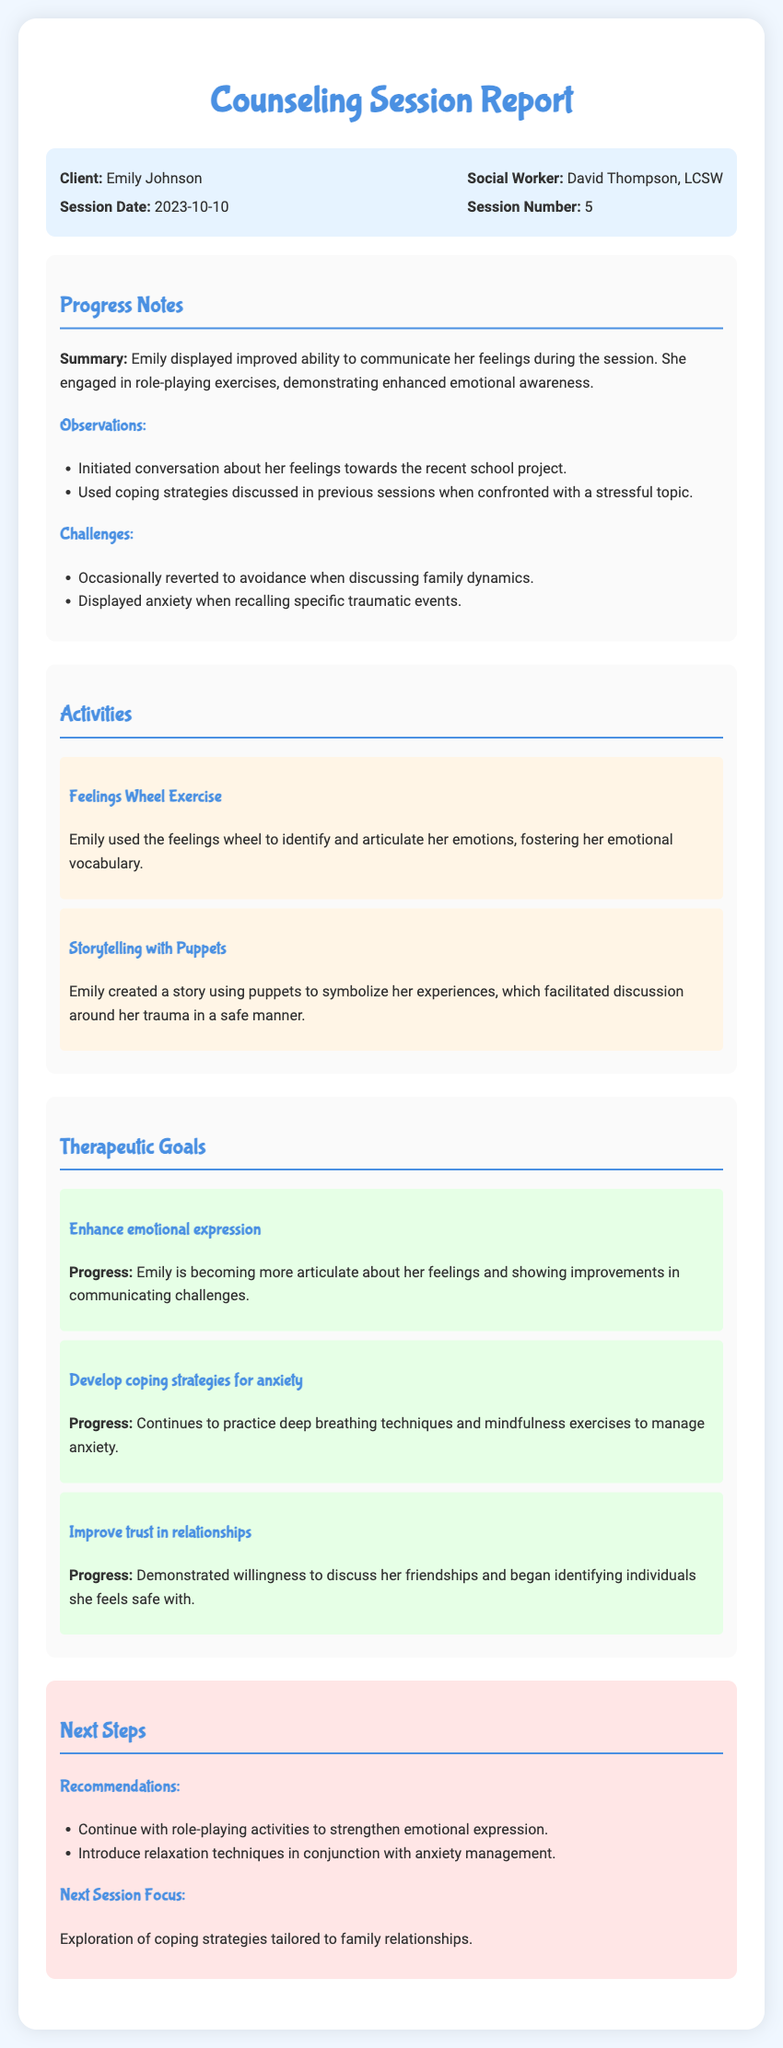What is the client’s name? The client's name is listed at the beginning of the document under the "Client" section.
Answer: Emily Johnson What is the session date? The session date is specified in the header information of the document.
Answer: 2023-10-10 Who is the social worker? The name of the social worker is provided in the header information.
Answer: David Thompson, LCSW What session number is this report for? The session number can be found in the header information alongside the client's name.
Answer: 5 What activity involved using puppets? The specific activity using puppets is detailed in the "Activities" section of the document.
Answer: Storytelling with Puppets What is one coping strategy Emily continues to practice? The coping strategies are listed under the "Therapeutic Goals" section. The answer is derived from the details of her progress.
Answer: Deep breathing techniques How is Emily improving in emotional expression? This information is summarized in the "Therapeutic Goals" section and reflects her progress.
Answer: Becoming more articulate about her feelings What will be the focus of the next session? The focus for the next session is noted in the "Next Steps" section where recommendations are provided.
Answer: Exploration of coping strategies tailored to family relationships 